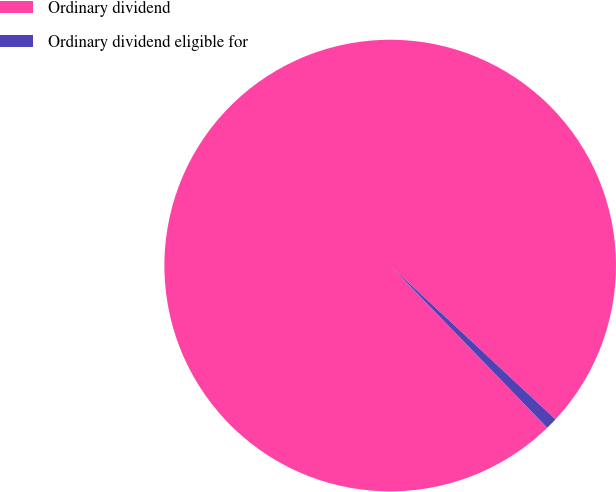Convert chart to OTSL. <chart><loc_0><loc_0><loc_500><loc_500><pie_chart><fcel>Ordinary dividend<fcel>Ordinary dividend eligible for<nl><fcel>99.17%<fcel>0.83%<nl></chart> 